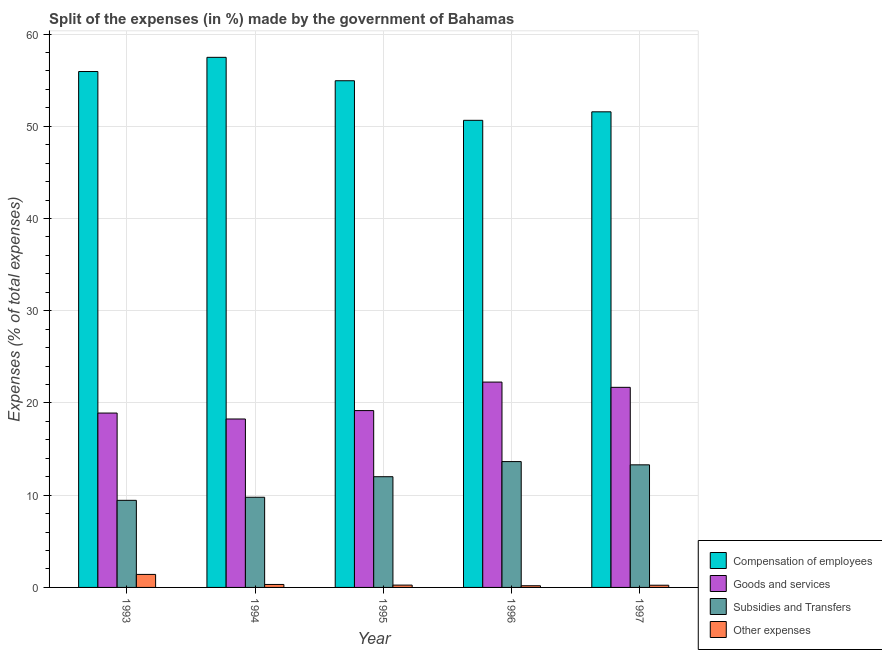How many different coloured bars are there?
Your response must be concise. 4. Are the number of bars on each tick of the X-axis equal?
Your answer should be very brief. Yes. How many bars are there on the 3rd tick from the left?
Provide a succinct answer. 4. What is the label of the 2nd group of bars from the left?
Provide a short and direct response. 1994. In how many cases, is the number of bars for a given year not equal to the number of legend labels?
Give a very brief answer. 0. What is the percentage of amount spent on compensation of employees in 1996?
Ensure brevity in your answer.  50.65. Across all years, what is the maximum percentage of amount spent on other expenses?
Provide a short and direct response. 1.41. Across all years, what is the minimum percentage of amount spent on subsidies?
Keep it short and to the point. 9.44. In which year was the percentage of amount spent on subsidies minimum?
Give a very brief answer. 1993. What is the total percentage of amount spent on subsidies in the graph?
Offer a very short reply. 58.16. What is the difference between the percentage of amount spent on subsidies in 1993 and that in 1997?
Offer a terse response. -3.85. What is the difference between the percentage of amount spent on goods and services in 1995 and the percentage of amount spent on other expenses in 1994?
Offer a very short reply. 0.91. What is the average percentage of amount spent on compensation of employees per year?
Make the answer very short. 54.11. In the year 1996, what is the difference between the percentage of amount spent on other expenses and percentage of amount spent on subsidies?
Your answer should be very brief. 0. In how many years, is the percentage of amount spent on other expenses greater than 44 %?
Make the answer very short. 0. What is the ratio of the percentage of amount spent on goods and services in 1994 to that in 1996?
Your response must be concise. 0.82. What is the difference between the highest and the second highest percentage of amount spent on other expenses?
Your answer should be very brief. 1.09. What is the difference between the highest and the lowest percentage of amount spent on other expenses?
Keep it short and to the point. 1.23. In how many years, is the percentage of amount spent on subsidies greater than the average percentage of amount spent on subsidies taken over all years?
Your answer should be very brief. 3. Is it the case that in every year, the sum of the percentage of amount spent on other expenses and percentage of amount spent on subsidies is greater than the sum of percentage of amount spent on compensation of employees and percentage of amount spent on goods and services?
Keep it short and to the point. No. What does the 1st bar from the left in 1997 represents?
Your response must be concise. Compensation of employees. What does the 3rd bar from the right in 1995 represents?
Provide a succinct answer. Goods and services. Is it the case that in every year, the sum of the percentage of amount spent on compensation of employees and percentage of amount spent on goods and services is greater than the percentage of amount spent on subsidies?
Keep it short and to the point. Yes. How many bars are there?
Ensure brevity in your answer.  20. Are all the bars in the graph horizontal?
Your answer should be compact. No. Where does the legend appear in the graph?
Your answer should be compact. Bottom right. How many legend labels are there?
Offer a very short reply. 4. What is the title of the graph?
Ensure brevity in your answer.  Split of the expenses (in %) made by the government of Bahamas. Does "Services" appear as one of the legend labels in the graph?
Provide a succinct answer. No. What is the label or title of the Y-axis?
Give a very brief answer. Expenses (% of total expenses). What is the Expenses (% of total expenses) in Compensation of employees in 1993?
Give a very brief answer. 55.94. What is the Expenses (% of total expenses) in Goods and services in 1993?
Your answer should be very brief. 18.91. What is the Expenses (% of total expenses) in Subsidies and Transfers in 1993?
Your answer should be compact. 9.44. What is the Expenses (% of total expenses) of Other expenses in 1993?
Offer a very short reply. 1.41. What is the Expenses (% of total expenses) in Compensation of employees in 1994?
Your response must be concise. 57.48. What is the Expenses (% of total expenses) of Goods and services in 1994?
Make the answer very short. 18.26. What is the Expenses (% of total expenses) of Subsidies and Transfers in 1994?
Provide a succinct answer. 9.78. What is the Expenses (% of total expenses) in Other expenses in 1994?
Your answer should be very brief. 0.32. What is the Expenses (% of total expenses) in Compensation of employees in 1995?
Offer a terse response. 54.94. What is the Expenses (% of total expenses) in Goods and services in 1995?
Your answer should be very brief. 19.17. What is the Expenses (% of total expenses) of Subsidies and Transfers in 1995?
Offer a very short reply. 12. What is the Expenses (% of total expenses) in Other expenses in 1995?
Ensure brevity in your answer.  0.25. What is the Expenses (% of total expenses) of Compensation of employees in 1996?
Your answer should be compact. 50.65. What is the Expenses (% of total expenses) in Goods and services in 1996?
Keep it short and to the point. 22.26. What is the Expenses (% of total expenses) of Subsidies and Transfers in 1996?
Provide a succinct answer. 13.64. What is the Expenses (% of total expenses) in Other expenses in 1996?
Your response must be concise. 0.18. What is the Expenses (% of total expenses) of Compensation of employees in 1997?
Make the answer very short. 51.57. What is the Expenses (% of total expenses) in Goods and services in 1997?
Your response must be concise. 21.7. What is the Expenses (% of total expenses) of Subsidies and Transfers in 1997?
Provide a short and direct response. 13.29. What is the Expenses (% of total expenses) of Other expenses in 1997?
Offer a very short reply. 0.24. Across all years, what is the maximum Expenses (% of total expenses) of Compensation of employees?
Your response must be concise. 57.48. Across all years, what is the maximum Expenses (% of total expenses) in Goods and services?
Make the answer very short. 22.26. Across all years, what is the maximum Expenses (% of total expenses) in Subsidies and Transfers?
Provide a short and direct response. 13.64. Across all years, what is the maximum Expenses (% of total expenses) in Other expenses?
Make the answer very short. 1.41. Across all years, what is the minimum Expenses (% of total expenses) of Compensation of employees?
Offer a terse response. 50.65. Across all years, what is the minimum Expenses (% of total expenses) in Goods and services?
Offer a very short reply. 18.26. Across all years, what is the minimum Expenses (% of total expenses) in Subsidies and Transfers?
Give a very brief answer. 9.44. Across all years, what is the minimum Expenses (% of total expenses) of Other expenses?
Provide a succinct answer. 0.18. What is the total Expenses (% of total expenses) in Compensation of employees in the graph?
Your answer should be very brief. 270.56. What is the total Expenses (% of total expenses) in Goods and services in the graph?
Make the answer very short. 100.3. What is the total Expenses (% of total expenses) in Subsidies and Transfers in the graph?
Offer a terse response. 58.16. What is the total Expenses (% of total expenses) of Other expenses in the graph?
Offer a very short reply. 2.41. What is the difference between the Expenses (% of total expenses) in Compensation of employees in 1993 and that in 1994?
Offer a very short reply. -1.54. What is the difference between the Expenses (% of total expenses) of Goods and services in 1993 and that in 1994?
Your answer should be very brief. 0.64. What is the difference between the Expenses (% of total expenses) in Subsidies and Transfers in 1993 and that in 1994?
Provide a short and direct response. -0.33. What is the difference between the Expenses (% of total expenses) in Other expenses in 1993 and that in 1994?
Your response must be concise. 1.09. What is the difference between the Expenses (% of total expenses) of Compensation of employees in 1993 and that in 1995?
Provide a succinct answer. 1. What is the difference between the Expenses (% of total expenses) of Goods and services in 1993 and that in 1995?
Make the answer very short. -0.27. What is the difference between the Expenses (% of total expenses) in Subsidies and Transfers in 1993 and that in 1995?
Keep it short and to the point. -2.56. What is the difference between the Expenses (% of total expenses) of Other expenses in 1993 and that in 1995?
Ensure brevity in your answer.  1.16. What is the difference between the Expenses (% of total expenses) in Compensation of employees in 1993 and that in 1996?
Provide a short and direct response. 5.29. What is the difference between the Expenses (% of total expenses) in Goods and services in 1993 and that in 1996?
Make the answer very short. -3.36. What is the difference between the Expenses (% of total expenses) of Subsidies and Transfers in 1993 and that in 1996?
Offer a very short reply. -4.2. What is the difference between the Expenses (% of total expenses) of Other expenses in 1993 and that in 1996?
Provide a short and direct response. 1.23. What is the difference between the Expenses (% of total expenses) in Compensation of employees in 1993 and that in 1997?
Provide a succinct answer. 4.37. What is the difference between the Expenses (% of total expenses) of Goods and services in 1993 and that in 1997?
Your response must be concise. -2.79. What is the difference between the Expenses (% of total expenses) in Subsidies and Transfers in 1993 and that in 1997?
Give a very brief answer. -3.85. What is the difference between the Expenses (% of total expenses) of Other expenses in 1993 and that in 1997?
Provide a short and direct response. 1.17. What is the difference between the Expenses (% of total expenses) in Compensation of employees in 1994 and that in 1995?
Your answer should be compact. 2.54. What is the difference between the Expenses (% of total expenses) in Goods and services in 1994 and that in 1995?
Offer a terse response. -0.91. What is the difference between the Expenses (% of total expenses) of Subsidies and Transfers in 1994 and that in 1995?
Make the answer very short. -2.23. What is the difference between the Expenses (% of total expenses) of Other expenses in 1994 and that in 1995?
Provide a short and direct response. 0.07. What is the difference between the Expenses (% of total expenses) of Compensation of employees in 1994 and that in 1996?
Your answer should be compact. 6.83. What is the difference between the Expenses (% of total expenses) in Goods and services in 1994 and that in 1996?
Keep it short and to the point. -4. What is the difference between the Expenses (% of total expenses) of Subsidies and Transfers in 1994 and that in 1996?
Your answer should be compact. -3.87. What is the difference between the Expenses (% of total expenses) in Other expenses in 1994 and that in 1996?
Provide a succinct answer. 0.14. What is the difference between the Expenses (% of total expenses) in Compensation of employees in 1994 and that in 1997?
Provide a succinct answer. 5.91. What is the difference between the Expenses (% of total expenses) in Goods and services in 1994 and that in 1997?
Keep it short and to the point. -3.43. What is the difference between the Expenses (% of total expenses) of Subsidies and Transfers in 1994 and that in 1997?
Provide a succinct answer. -3.52. What is the difference between the Expenses (% of total expenses) of Other expenses in 1994 and that in 1997?
Your answer should be very brief. 0.08. What is the difference between the Expenses (% of total expenses) of Compensation of employees in 1995 and that in 1996?
Keep it short and to the point. 4.29. What is the difference between the Expenses (% of total expenses) in Goods and services in 1995 and that in 1996?
Offer a very short reply. -3.09. What is the difference between the Expenses (% of total expenses) in Subsidies and Transfers in 1995 and that in 1996?
Keep it short and to the point. -1.64. What is the difference between the Expenses (% of total expenses) of Other expenses in 1995 and that in 1996?
Make the answer very short. 0.07. What is the difference between the Expenses (% of total expenses) in Compensation of employees in 1995 and that in 1997?
Your answer should be compact. 3.37. What is the difference between the Expenses (% of total expenses) in Goods and services in 1995 and that in 1997?
Your answer should be compact. -2.52. What is the difference between the Expenses (% of total expenses) in Subsidies and Transfers in 1995 and that in 1997?
Provide a succinct answer. -1.29. What is the difference between the Expenses (% of total expenses) in Other expenses in 1995 and that in 1997?
Make the answer very short. 0.01. What is the difference between the Expenses (% of total expenses) in Compensation of employees in 1996 and that in 1997?
Keep it short and to the point. -0.92. What is the difference between the Expenses (% of total expenses) of Goods and services in 1996 and that in 1997?
Ensure brevity in your answer.  0.57. What is the difference between the Expenses (% of total expenses) of Subsidies and Transfers in 1996 and that in 1997?
Offer a terse response. 0.35. What is the difference between the Expenses (% of total expenses) of Other expenses in 1996 and that in 1997?
Provide a succinct answer. -0.06. What is the difference between the Expenses (% of total expenses) in Compensation of employees in 1993 and the Expenses (% of total expenses) in Goods and services in 1994?
Your answer should be very brief. 37.67. What is the difference between the Expenses (% of total expenses) of Compensation of employees in 1993 and the Expenses (% of total expenses) of Subsidies and Transfers in 1994?
Offer a terse response. 46.16. What is the difference between the Expenses (% of total expenses) in Compensation of employees in 1993 and the Expenses (% of total expenses) in Other expenses in 1994?
Offer a very short reply. 55.61. What is the difference between the Expenses (% of total expenses) in Goods and services in 1993 and the Expenses (% of total expenses) in Subsidies and Transfers in 1994?
Make the answer very short. 9.13. What is the difference between the Expenses (% of total expenses) of Goods and services in 1993 and the Expenses (% of total expenses) of Other expenses in 1994?
Provide a succinct answer. 18.58. What is the difference between the Expenses (% of total expenses) in Subsidies and Transfers in 1993 and the Expenses (% of total expenses) in Other expenses in 1994?
Ensure brevity in your answer.  9.12. What is the difference between the Expenses (% of total expenses) of Compensation of employees in 1993 and the Expenses (% of total expenses) of Goods and services in 1995?
Ensure brevity in your answer.  36.76. What is the difference between the Expenses (% of total expenses) in Compensation of employees in 1993 and the Expenses (% of total expenses) in Subsidies and Transfers in 1995?
Offer a very short reply. 43.93. What is the difference between the Expenses (% of total expenses) in Compensation of employees in 1993 and the Expenses (% of total expenses) in Other expenses in 1995?
Offer a very short reply. 55.69. What is the difference between the Expenses (% of total expenses) in Goods and services in 1993 and the Expenses (% of total expenses) in Subsidies and Transfers in 1995?
Your response must be concise. 6.9. What is the difference between the Expenses (% of total expenses) of Goods and services in 1993 and the Expenses (% of total expenses) of Other expenses in 1995?
Offer a terse response. 18.65. What is the difference between the Expenses (% of total expenses) in Subsidies and Transfers in 1993 and the Expenses (% of total expenses) in Other expenses in 1995?
Offer a very short reply. 9.19. What is the difference between the Expenses (% of total expenses) of Compensation of employees in 1993 and the Expenses (% of total expenses) of Goods and services in 1996?
Offer a very short reply. 33.67. What is the difference between the Expenses (% of total expenses) in Compensation of employees in 1993 and the Expenses (% of total expenses) in Subsidies and Transfers in 1996?
Offer a terse response. 42.29. What is the difference between the Expenses (% of total expenses) of Compensation of employees in 1993 and the Expenses (% of total expenses) of Other expenses in 1996?
Keep it short and to the point. 55.75. What is the difference between the Expenses (% of total expenses) of Goods and services in 1993 and the Expenses (% of total expenses) of Subsidies and Transfers in 1996?
Offer a terse response. 5.26. What is the difference between the Expenses (% of total expenses) in Goods and services in 1993 and the Expenses (% of total expenses) in Other expenses in 1996?
Offer a very short reply. 18.72. What is the difference between the Expenses (% of total expenses) of Subsidies and Transfers in 1993 and the Expenses (% of total expenses) of Other expenses in 1996?
Your answer should be very brief. 9.26. What is the difference between the Expenses (% of total expenses) of Compensation of employees in 1993 and the Expenses (% of total expenses) of Goods and services in 1997?
Offer a very short reply. 34.24. What is the difference between the Expenses (% of total expenses) of Compensation of employees in 1993 and the Expenses (% of total expenses) of Subsidies and Transfers in 1997?
Make the answer very short. 42.64. What is the difference between the Expenses (% of total expenses) in Compensation of employees in 1993 and the Expenses (% of total expenses) in Other expenses in 1997?
Provide a succinct answer. 55.7. What is the difference between the Expenses (% of total expenses) of Goods and services in 1993 and the Expenses (% of total expenses) of Subsidies and Transfers in 1997?
Ensure brevity in your answer.  5.61. What is the difference between the Expenses (% of total expenses) in Goods and services in 1993 and the Expenses (% of total expenses) in Other expenses in 1997?
Ensure brevity in your answer.  18.67. What is the difference between the Expenses (% of total expenses) in Subsidies and Transfers in 1993 and the Expenses (% of total expenses) in Other expenses in 1997?
Provide a succinct answer. 9.2. What is the difference between the Expenses (% of total expenses) of Compensation of employees in 1994 and the Expenses (% of total expenses) of Goods and services in 1995?
Make the answer very short. 38.3. What is the difference between the Expenses (% of total expenses) of Compensation of employees in 1994 and the Expenses (% of total expenses) of Subsidies and Transfers in 1995?
Your response must be concise. 45.47. What is the difference between the Expenses (% of total expenses) of Compensation of employees in 1994 and the Expenses (% of total expenses) of Other expenses in 1995?
Ensure brevity in your answer.  57.22. What is the difference between the Expenses (% of total expenses) of Goods and services in 1994 and the Expenses (% of total expenses) of Subsidies and Transfers in 1995?
Give a very brief answer. 6.26. What is the difference between the Expenses (% of total expenses) of Goods and services in 1994 and the Expenses (% of total expenses) of Other expenses in 1995?
Your answer should be very brief. 18.01. What is the difference between the Expenses (% of total expenses) of Subsidies and Transfers in 1994 and the Expenses (% of total expenses) of Other expenses in 1995?
Your answer should be very brief. 9.52. What is the difference between the Expenses (% of total expenses) of Compensation of employees in 1994 and the Expenses (% of total expenses) of Goods and services in 1996?
Provide a succinct answer. 35.21. What is the difference between the Expenses (% of total expenses) of Compensation of employees in 1994 and the Expenses (% of total expenses) of Subsidies and Transfers in 1996?
Offer a very short reply. 43.83. What is the difference between the Expenses (% of total expenses) of Compensation of employees in 1994 and the Expenses (% of total expenses) of Other expenses in 1996?
Keep it short and to the point. 57.29. What is the difference between the Expenses (% of total expenses) of Goods and services in 1994 and the Expenses (% of total expenses) of Subsidies and Transfers in 1996?
Offer a very short reply. 4.62. What is the difference between the Expenses (% of total expenses) of Goods and services in 1994 and the Expenses (% of total expenses) of Other expenses in 1996?
Your answer should be compact. 18.08. What is the difference between the Expenses (% of total expenses) in Subsidies and Transfers in 1994 and the Expenses (% of total expenses) in Other expenses in 1996?
Provide a succinct answer. 9.59. What is the difference between the Expenses (% of total expenses) of Compensation of employees in 1994 and the Expenses (% of total expenses) of Goods and services in 1997?
Keep it short and to the point. 35.78. What is the difference between the Expenses (% of total expenses) in Compensation of employees in 1994 and the Expenses (% of total expenses) in Subsidies and Transfers in 1997?
Your answer should be compact. 44.18. What is the difference between the Expenses (% of total expenses) of Compensation of employees in 1994 and the Expenses (% of total expenses) of Other expenses in 1997?
Give a very brief answer. 57.24. What is the difference between the Expenses (% of total expenses) in Goods and services in 1994 and the Expenses (% of total expenses) in Subsidies and Transfers in 1997?
Provide a succinct answer. 4.97. What is the difference between the Expenses (% of total expenses) in Goods and services in 1994 and the Expenses (% of total expenses) in Other expenses in 1997?
Your answer should be compact. 18.02. What is the difference between the Expenses (% of total expenses) of Subsidies and Transfers in 1994 and the Expenses (% of total expenses) of Other expenses in 1997?
Keep it short and to the point. 9.54. What is the difference between the Expenses (% of total expenses) of Compensation of employees in 1995 and the Expenses (% of total expenses) of Goods and services in 1996?
Offer a very short reply. 32.67. What is the difference between the Expenses (% of total expenses) in Compensation of employees in 1995 and the Expenses (% of total expenses) in Subsidies and Transfers in 1996?
Your answer should be very brief. 41.29. What is the difference between the Expenses (% of total expenses) in Compensation of employees in 1995 and the Expenses (% of total expenses) in Other expenses in 1996?
Offer a very short reply. 54.75. What is the difference between the Expenses (% of total expenses) in Goods and services in 1995 and the Expenses (% of total expenses) in Subsidies and Transfers in 1996?
Give a very brief answer. 5.53. What is the difference between the Expenses (% of total expenses) in Goods and services in 1995 and the Expenses (% of total expenses) in Other expenses in 1996?
Ensure brevity in your answer.  18.99. What is the difference between the Expenses (% of total expenses) in Subsidies and Transfers in 1995 and the Expenses (% of total expenses) in Other expenses in 1996?
Provide a short and direct response. 11.82. What is the difference between the Expenses (% of total expenses) in Compensation of employees in 1995 and the Expenses (% of total expenses) in Goods and services in 1997?
Make the answer very short. 33.24. What is the difference between the Expenses (% of total expenses) of Compensation of employees in 1995 and the Expenses (% of total expenses) of Subsidies and Transfers in 1997?
Your response must be concise. 41.64. What is the difference between the Expenses (% of total expenses) in Compensation of employees in 1995 and the Expenses (% of total expenses) in Other expenses in 1997?
Your answer should be very brief. 54.7. What is the difference between the Expenses (% of total expenses) in Goods and services in 1995 and the Expenses (% of total expenses) in Subsidies and Transfers in 1997?
Give a very brief answer. 5.88. What is the difference between the Expenses (% of total expenses) of Goods and services in 1995 and the Expenses (% of total expenses) of Other expenses in 1997?
Your response must be concise. 18.94. What is the difference between the Expenses (% of total expenses) in Subsidies and Transfers in 1995 and the Expenses (% of total expenses) in Other expenses in 1997?
Your response must be concise. 11.77. What is the difference between the Expenses (% of total expenses) in Compensation of employees in 1996 and the Expenses (% of total expenses) in Goods and services in 1997?
Offer a terse response. 28.95. What is the difference between the Expenses (% of total expenses) in Compensation of employees in 1996 and the Expenses (% of total expenses) in Subsidies and Transfers in 1997?
Your response must be concise. 37.35. What is the difference between the Expenses (% of total expenses) in Compensation of employees in 1996 and the Expenses (% of total expenses) in Other expenses in 1997?
Offer a terse response. 50.41. What is the difference between the Expenses (% of total expenses) of Goods and services in 1996 and the Expenses (% of total expenses) of Subsidies and Transfers in 1997?
Ensure brevity in your answer.  8.97. What is the difference between the Expenses (% of total expenses) of Goods and services in 1996 and the Expenses (% of total expenses) of Other expenses in 1997?
Offer a very short reply. 22.03. What is the difference between the Expenses (% of total expenses) of Subsidies and Transfers in 1996 and the Expenses (% of total expenses) of Other expenses in 1997?
Ensure brevity in your answer.  13.41. What is the average Expenses (% of total expenses) of Compensation of employees per year?
Ensure brevity in your answer.  54.11. What is the average Expenses (% of total expenses) in Goods and services per year?
Give a very brief answer. 20.06. What is the average Expenses (% of total expenses) of Subsidies and Transfers per year?
Offer a very short reply. 11.63. What is the average Expenses (% of total expenses) in Other expenses per year?
Make the answer very short. 0.48. In the year 1993, what is the difference between the Expenses (% of total expenses) in Compensation of employees and Expenses (% of total expenses) in Goods and services?
Offer a terse response. 37.03. In the year 1993, what is the difference between the Expenses (% of total expenses) in Compensation of employees and Expenses (% of total expenses) in Subsidies and Transfers?
Offer a terse response. 46.49. In the year 1993, what is the difference between the Expenses (% of total expenses) of Compensation of employees and Expenses (% of total expenses) of Other expenses?
Provide a short and direct response. 54.53. In the year 1993, what is the difference between the Expenses (% of total expenses) in Goods and services and Expenses (% of total expenses) in Subsidies and Transfers?
Keep it short and to the point. 9.46. In the year 1993, what is the difference between the Expenses (% of total expenses) of Goods and services and Expenses (% of total expenses) of Other expenses?
Give a very brief answer. 17.5. In the year 1993, what is the difference between the Expenses (% of total expenses) in Subsidies and Transfers and Expenses (% of total expenses) in Other expenses?
Your answer should be compact. 8.03. In the year 1994, what is the difference between the Expenses (% of total expenses) of Compensation of employees and Expenses (% of total expenses) of Goods and services?
Provide a succinct answer. 39.21. In the year 1994, what is the difference between the Expenses (% of total expenses) in Compensation of employees and Expenses (% of total expenses) in Subsidies and Transfers?
Make the answer very short. 47.7. In the year 1994, what is the difference between the Expenses (% of total expenses) in Compensation of employees and Expenses (% of total expenses) in Other expenses?
Keep it short and to the point. 57.15. In the year 1994, what is the difference between the Expenses (% of total expenses) in Goods and services and Expenses (% of total expenses) in Subsidies and Transfers?
Offer a very short reply. 8.49. In the year 1994, what is the difference between the Expenses (% of total expenses) of Goods and services and Expenses (% of total expenses) of Other expenses?
Your response must be concise. 17.94. In the year 1994, what is the difference between the Expenses (% of total expenses) in Subsidies and Transfers and Expenses (% of total expenses) in Other expenses?
Make the answer very short. 9.45. In the year 1995, what is the difference between the Expenses (% of total expenses) in Compensation of employees and Expenses (% of total expenses) in Goods and services?
Your response must be concise. 35.76. In the year 1995, what is the difference between the Expenses (% of total expenses) in Compensation of employees and Expenses (% of total expenses) in Subsidies and Transfers?
Offer a very short reply. 42.93. In the year 1995, what is the difference between the Expenses (% of total expenses) in Compensation of employees and Expenses (% of total expenses) in Other expenses?
Provide a succinct answer. 54.68. In the year 1995, what is the difference between the Expenses (% of total expenses) in Goods and services and Expenses (% of total expenses) in Subsidies and Transfers?
Ensure brevity in your answer.  7.17. In the year 1995, what is the difference between the Expenses (% of total expenses) in Goods and services and Expenses (% of total expenses) in Other expenses?
Offer a very short reply. 18.92. In the year 1995, what is the difference between the Expenses (% of total expenses) in Subsidies and Transfers and Expenses (% of total expenses) in Other expenses?
Offer a very short reply. 11.75. In the year 1996, what is the difference between the Expenses (% of total expenses) in Compensation of employees and Expenses (% of total expenses) in Goods and services?
Give a very brief answer. 28.38. In the year 1996, what is the difference between the Expenses (% of total expenses) in Compensation of employees and Expenses (% of total expenses) in Subsidies and Transfers?
Ensure brevity in your answer.  37. In the year 1996, what is the difference between the Expenses (% of total expenses) in Compensation of employees and Expenses (% of total expenses) in Other expenses?
Your answer should be compact. 50.46. In the year 1996, what is the difference between the Expenses (% of total expenses) in Goods and services and Expenses (% of total expenses) in Subsidies and Transfers?
Make the answer very short. 8.62. In the year 1996, what is the difference between the Expenses (% of total expenses) of Goods and services and Expenses (% of total expenses) of Other expenses?
Your answer should be compact. 22.08. In the year 1996, what is the difference between the Expenses (% of total expenses) of Subsidies and Transfers and Expenses (% of total expenses) of Other expenses?
Make the answer very short. 13.46. In the year 1997, what is the difference between the Expenses (% of total expenses) of Compensation of employees and Expenses (% of total expenses) of Goods and services?
Provide a succinct answer. 29.87. In the year 1997, what is the difference between the Expenses (% of total expenses) of Compensation of employees and Expenses (% of total expenses) of Subsidies and Transfers?
Your response must be concise. 38.28. In the year 1997, what is the difference between the Expenses (% of total expenses) in Compensation of employees and Expenses (% of total expenses) in Other expenses?
Your response must be concise. 51.33. In the year 1997, what is the difference between the Expenses (% of total expenses) of Goods and services and Expenses (% of total expenses) of Subsidies and Transfers?
Keep it short and to the point. 8.4. In the year 1997, what is the difference between the Expenses (% of total expenses) in Goods and services and Expenses (% of total expenses) in Other expenses?
Offer a terse response. 21.46. In the year 1997, what is the difference between the Expenses (% of total expenses) in Subsidies and Transfers and Expenses (% of total expenses) in Other expenses?
Offer a very short reply. 13.05. What is the ratio of the Expenses (% of total expenses) in Compensation of employees in 1993 to that in 1994?
Make the answer very short. 0.97. What is the ratio of the Expenses (% of total expenses) of Goods and services in 1993 to that in 1994?
Offer a terse response. 1.04. What is the ratio of the Expenses (% of total expenses) of Subsidies and Transfers in 1993 to that in 1994?
Your answer should be very brief. 0.97. What is the ratio of the Expenses (% of total expenses) of Other expenses in 1993 to that in 1994?
Your answer should be very brief. 4.38. What is the ratio of the Expenses (% of total expenses) in Compensation of employees in 1993 to that in 1995?
Your answer should be compact. 1.02. What is the ratio of the Expenses (% of total expenses) in Goods and services in 1993 to that in 1995?
Your response must be concise. 0.99. What is the ratio of the Expenses (% of total expenses) of Subsidies and Transfers in 1993 to that in 1995?
Make the answer very short. 0.79. What is the ratio of the Expenses (% of total expenses) in Other expenses in 1993 to that in 1995?
Provide a short and direct response. 5.6. What is the ratio of the Expenses (% of total expenses) in Compensation of employees in 1993 to that in 1996?
Your response must be concise. 1.1. What is the ratio of the Expenses (% of total expenses) of Goods and services in 1993 to that in 1996?
Your response must be concise. 0.85. What is the ratio of the Expenses (% of total expenses) in Subsidies and Transfers in 1993 to that in 1996?
Provide a succinct answer. 0.69. What is the ratio of the Expenses (% of total expenses) in Other expenses in 1993 to that in 1996?
Your answer should be very brief. 7.74. What is the ratio of the Expenses (% of total expenses) of Compensation of employees in 1993 to that in 1997?
Your response must be concise. 1.08. What is the ratio of the Expenses (% of total expenses) in Goods and services in 1993 to that in 1997?
Provide a short and direct response. 0.87. What is the ratio of the Expenses (% of total expenses) in Subsidies and Transfers in 1993 to that in 1997?
Provide a short and direct response. 0.71. What is the ratio of the Expenses (% of total expenses) in Other expenses in 1993 to that in 1997?
Offer a very short reply. 5.9. What is the ratio of the Expenses (% of total expenses) in Compensation of employees in 1994 to that in 1995?
Provide a short and direct response. 1.05. What is the ratio of the Expenses (% of total expenses) of Goods and services in 1994 to that in 1995?
Make the answer very short. 0.95. What is the ratio of the Expenses (% of total expenses) of Subsidies and Transfers in 1994 to that in 1995?
Your answer should be very brief. 0.81. What is the ratio of the Expenses (% of total expenses) in Other expenses in 1994 to that in 1995?
Ensure brevity in your answer.  1.28. What is the ratio of the Expenses (% of total expenses) in Compensation of employees in 1994 to that in 1996?
Offer a very short reply. 1.13. What is the ratio of the Expenses (% of total expenses) in Goods and services in 1994 to that in 1996?
Your answer should be compact. 0.82. What is the ratio of the Expenses (% of total expenses) of Subsidies and Transfers in 1994 to that in 1996?
Keep it short and to the point. 0.72. What is the ratio of the Expenses (% of total expenses) of Other expenses in 1994 to that in 1996?
Your answer should be compact. 1.77. What is the ratio of the Expenses (% of total expenses) in Compensation of employees in 1994 to that in 1997?
Give a very brief answer. 1.11. What is the ratio of the Expenses (% of total expenses) in Goods and services in 1994 to that in 1997?
Offer a very short reply. 0.84. What is the ratio of the Expenses (% of total expenses) of Subsidies and Transfers in 1994 to that in 1997?
Offer a very short reply. 0.74. What is the ratio of the Expenses (% of total expenses) in Other expenses in 1994 to that in 1997?
Your response must be concise. 1.35. What is the ratio of the Expenses (% of total expenses) of Compensation of employees in 1995 to that in 1996?
Make the answer very short. 1.08. What is the ratio of the Expenses (% of total expenses) of Goods and services in 1995 to that in 1996?
Your answer should be very brief. 0.86. What is the ratio of the Expenses (% of total expenses) of Subsidies and Transfers in 1995 to that in 1996?
Provide a short and direct response. 0.88. What is the ratio of the Expenses (% of total expenses) in Other expenses in 1995 to that in 1996?
Your answer should be compact. 1.38. What is the ratio of the Expenses (% of total expenses) in Compensation of employees in 1995 to that in 1997?
Your answer should be compact. 1.07. What is the ratio of the Expenses (% of total expenses) in Goods and services in 1995 to that in 1997?
Offer a terse response. 0.88. What is the ratio of the Expenses (% of total expenses) of Subsidies and Transfers in 1995 to that in 1997?
Make the answer very short. 0.9. What is the ratio of the Expenses (% of total expenses) in Other expenses in 1995 to that in 1997?
Give a very brief answer. 1.05. What is the ratio of the Expenses (% of total expenses) in Compensation of employees in 1996 to that in 1997?
Offer a very short reply. 0.98. What is the ratio of the Expenses (% of total expenses) of Goods and services in 1996 to that in 1997?
Your answer should be very brief. 1.03. What is the ratio of the Expenses (% of total expenses) in Subsidies and Transfers in 1996 to that in 1997?
Offer a terse response. 1.03. What is the ratio of the Expenses (% of total expenses) of Other expenses in 1996 to that in 1997?
Keep it short and to the point. 0.76. What is the difference between the highest and the second highest Expenses (% of total expenses) in Compensation of employees?
Keep it short and to the point. 1.54. What is the difference between the highest and the second highest Expenses (% of total expenses) in Goods and services?
Keep it short and to the point. 0.57. What is the difference between the highest and the second highest Expenses (% of total expenses) in Subsidies and Transfers?
Provide a succinct answer. 0.35. What is the difference between the highest and the second highest Expenses (% of total expenses) in Other expenses?
Offer a very short reply. 1.09. What is the difference between the highest and the lowest Expenses (% of total expenses) of Compensation of employees?
Your response must be concise. 6.83. What is the difference between the highest and the lowest Expenses (% of total expenses) of Goods and services?
Your answer should be very brief. 4. What is the difference between the highest and the lowest Expenses (% of total expenses) of Subsidies and Transfers?
Ensure brevity in your answer.  4.2. What is the difference between the highest and the lowest Expenses (% of total expenses) in Other expenses?
Offer a very short reply. 1.23. 